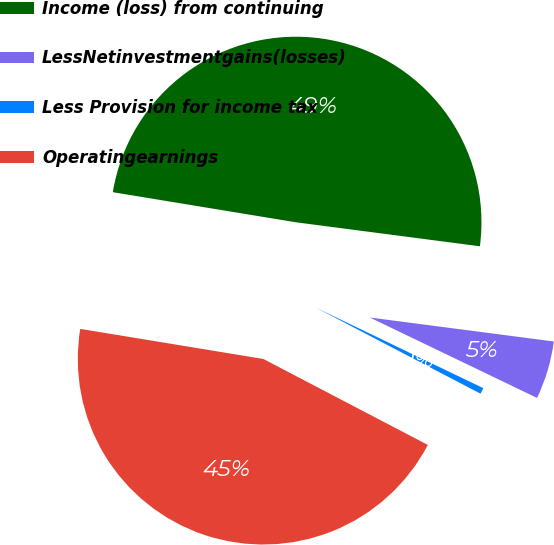Convert chart. <chart><loc_0><loc_0><loc_500><loc_500><pie_chart><fcel>Income (loss) from continuing<fcel>LessNetinvestmentgains(losses)<fcel>Less Provision for income tax<fcel>Operatingearnings<nl><fcel>49.47%<fcel>5.07%<fcel>0.53%<fcel>44.93%<nl></chart> 